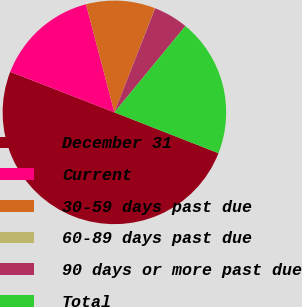Convert chart to OTSL. <chart><loc_0><loc_0><loc_500><loc_500><pie_chart><fcel>December 31<fcel>Current<fcel>30-59 days past due<fcel>60-89 days past due<fcel>90 days or more past due<fcel>Total<nl><fcel>49.96%<fcel>15.0%<fcel>10.01%<fcel>0.02%<fcel>5.01%<fcel>20.0%<nl></chart> 